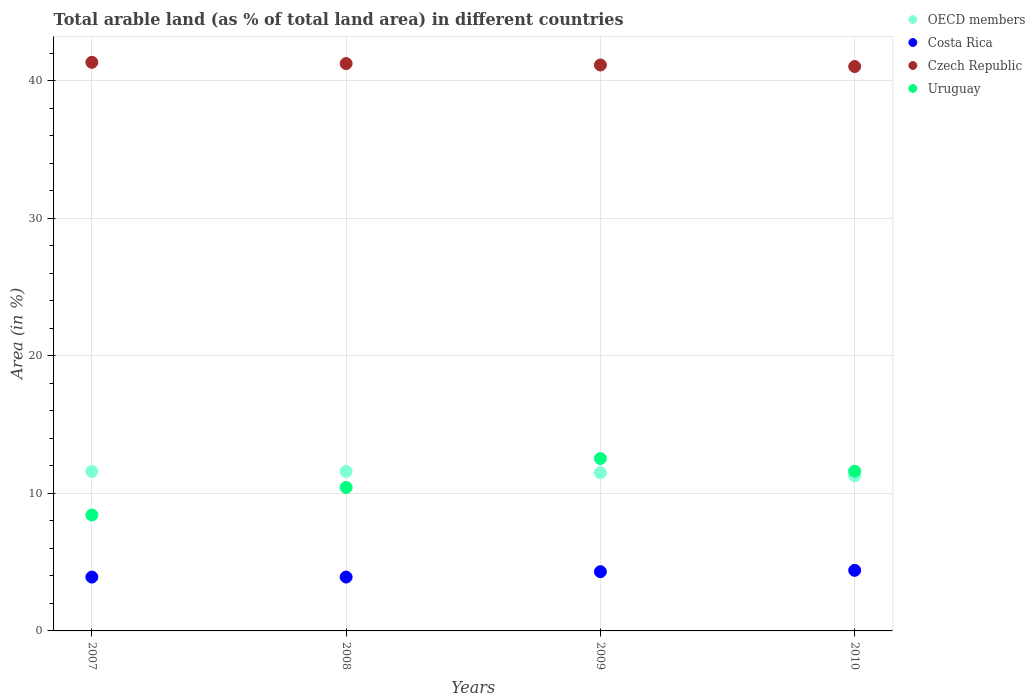What is the percentage of arable land in OECD members in 2009?
Your response must be concise. 11.5. Across all years, what is the maximum percentage of arable land in Costa Rica?
Make the answer very short. 4.41. Across all years, what is the minimum percentage of arable land in OECD members?
Offer a terse response. 11.29. What is the total percentage of arable land in Uruguay in the graph?
Your answer should be very brief. 43.02. What is the difference between the percentage of arable land in Czech Republic in 2007 and that in 2008?
Your answer should be very brief. 0.09. What is the difference between the percentage of arable land in Uruguay in 2007 and the percentage of arable land in Costa Rica in 2010?
Offer a terse response. 4.03. What is the average percentage of arable land in Uruguay per year?
Give a very brief answer. 10.76. In the year 2007, what is the difference between the percentage of arable land in Czech Republic and percentage of arable land in OECD members?
Ensure brevity in your answer.  29.76. In how many years, is the percentage of arable land in Uruguay greater than 40 %?
Your response must be concise. 0. What is the ratio of the percentage of arable land in Czech Republic in 2007 to that in 2009?
Offer a very short reply. 1. What is the difference between the highest and the second highest percentage of arable land in Costa Rica?
Make the answer very short. 0.1. What is the difference between the highest and the lowest percentage of arable land in OECD members?
Provide a short and direct response. 0.32. In how many years, is the percentage of arable land in Costa Rica greater than the average percentage of arable land in Costa Rica taken over all years?
Your answer should be very brief. 2. Is it the case that in every year, the sum of the percentage of arable land in Costa Rica and percentage of arable land in OECD members  is greater than the sum of percentage of arable land in Uruguay and percentage of arable land in Czech Republic?
Keep it short and to the point. No. How many dotlines are there?
Provide a succinct answer. 4. How many years are there in the graph?
Make the answer very short. 4. Are the values on the major ticks of Y-axis written in scientific E-notation?
Make the answer very short. No. Does the graph contain grids?
Your response must be concise. Yes. How are the legend labels stacked?
Offer a terse response. Vertical. What is the title of the graph?
Provide a short and direct response. Total arable land (as % of total land area) in different countries. What is the label or title of the X-axis?
Offer a very short reply. Years. What is the label or title of the Y-axis?
Ensure brevity in your answer.  Area (in %). What is the Area (in %) in OECD members in 2007?
Offer a terse response. 11.6. What is the Area (in %) of Costa Rica in 2007?
Offer a very short reply. 3.92. What is the Area (in %) of Czech Republic in 2007?
Provide a succinct answer. 41.36. What is the Area (in %) of Uruguay in 2007?
Give a very brief answer. 8.43. What is the Area (in %) in OECD members in 2008?
Offer a very short reply. 11.6. What is the Area (in %) in Costa Rica in 2008?
Provide a succinct answer. 3.92. What is the Area (in %) of Czech Republic in 2008?
Give a very brief answer. 41.27. What is the Area (in %) of Uruguay in 2008?
Give a very brief answer. 10.43. What is the Area (in %) in OECD members in 2009?
Offer a very short reply. 11.5. What is the Area (in %) of Costa Rica in 2009?
Your answer should be very brief. 4.31. What is the Area (in %) of Czech Republic in 2009?
Offer a terse response. 41.17. What is the Area (in %) of Uruguay in 2009?
Provide a short and direct response. 12.54. What is the Area (in %) of OECD members in 2010?
Provide a short and direct response. 11.29. What is the Area (in %) of Costa Rica in 2010?
Offer a very short reply. 4.41. What is the Area (in %) in Czech Republic in 2010?
Keep it short and to the point. 41.05. What is the Area (in %) in Uruguay in 2010?
Keep it short and to the point. 11.62. Across all years, what is the maximum Area (in %) of OECD members?
Keep it short and to the point. 11.6. Across all years, what is the maximum Area (in %) of Costa Rica?
Offer a very short reply. 4.41. Across all years, what is the maximum Area (in %) of Czech Republic?
Your answer should be very brief. 41.36. Across all years, what is the maximum Area (in %) of Uruguay?
Offer a terse response. 12.54. Across all years, what is the minimum Area (in %) in OECD members?
Your response must be concise. 11.29. Across all years, what is the minimum Area (in %) in Costa Rica?
Your answer should be compact. 3.92. Across all years, what is the minimum Area (in %) of Czech Republic?
Ensure brevity in your answer.  41.05. Across all years, what is the minimum Area (in %) in Uruguay?
Offer a terse response. 8.43. What is the total Area (in %) in OECD members in the graph?
Your answer should be compact. 45.99. What is the total Area (in %) of Costa Rica in the graph?
Provide a short and direct response. 16.55. What is the total Area (in %) of Czech Republic in the graph?
Keep it short and to the point. 164.85. What is the total Area (in %) of Uruguay in the graph?
Your response must be concise. 43.02. What is the difference between the Area (in %) in OECD members in 2007 and that in 2008?
Your answer should be compact. -0. What is the difference between the Area (in %) in Costa Rica in 2007 and that in 2008?
Your answer should be very brief. 0. What is the difference between the Area (in %) of Czech Republic in 2007 and that in 2008?
Make the answer very short. 0.09. What is the difference between the Area (in %) of Uruguay in 2007 and that in 2008?
Give a very brief answer. -2. What is the difference between the Area (in %) in OECD members in 2007 and that in 2009?
Keep it short and to the point. 0.1. What is the difference between the Area (in %) of Costa Rica in 2007 and that in 2009?
Offer a terse response. -0.39. What is the difference between the Area (in %) of Czech Republic in 2007 and that in 2009?
Keep it short and to the point. 0.19. What is the difference between the Area (in %) of Uruguay in 2007 and that in 2009?
Keep it short and to the point. -4.11. What is the difference between the Area (in %) in OECD members in 2007 and that in 2010?
Make the answer very short. 0.31. What is the difference between the Area (in %) of Costa Rica in 2007 and that in 2010?
Your answer should be very brief. -0.49. What is the difference between the Area (in %) of Czech Republic in 2007 and that in 2010?
Offer a very short reply. 0.31. What is the difference between the Area (in %) in Uruguay in 2007 and that in 2010?
Your answer should be very brief. -3.18. What is the difference between the Area (in %) in OECD members in 2008 and that in 2009?
Give a very brief answer. 0.1. What is the difference between the Area (in %) in Costa Rica in 2008 and that in 2009?
Your response must be concise. -0.39. What is the difference between the Area (in %) of Czech Republic in 2008 and that in 2009?
Keep it short and to the point. 0.1. What is the difference between the Area (in %) in Uruguay in 2008 and that in 2009?
Your answer should be compact. -2.11. What is the difference between the Area (in %) of OECD members in 2008 and that in 2010?
Provide a succinct answer. 0.32. What is the difference between the Area (in %) in Costa Rica in 2008 and that in 2010?
Offer a terse response. -0.49. What is the difference between the Area (in %) in Czech Republic in 2008 and that in 2010?
Keep it short and to the point. 0.21. What is the difference between the Area (in %) of Uruguay in 2008 and that in 2010?
Ensure brevity in your answer.  -1.18. What is the difference between the Area (in %) in OECD members in 2009 and that in 2010?
Offer a very short reply. 0.22. What is the difference between the Area (in %) of Costa Rica in 2009 and that in 2010?
Make the answer very short. -0.1. What is the difference between the Area (in %) in Czech Republic in 2009 and that in 2010?
Offer a very short reply. 0.11. What is the difference between the Area (in %) of Uruguay in 2009 and that in 2010?
Give a very brief answer. 0.93. What is the difference between the Area (in %) of OECD members in 2007 and the Area (in %) of Costa Rica in 2008?
Provide a short and direct response. 7.68. What is the difference between the Area (in %) of OECD members in 2007 and the Area (in %) of Czech Republic in 2008?
Offer a terse response. -29.67. What is the difference between the Area (in %) in OECD members in 2007 and the Area (in %) in Uruguay in 2008?
Your answer should be very brief. 1.17. What is the difference between the Area (in %) in Costa Rica in 2007 and the Area (in %) in Czech Republic in 2008?
Ensure brevity in your answer.  -37.35. What is the difference between the Area (in %) of Costa Rica in 2007 and the Area (in %) of Uruguay in 2008?
Offer a very short reply. -6.52. What is the difference between the Area (in %) of Czech Republic in 2007 and the Area (in %) of Uruguay in 2008?
Your answer should be very brief. 30.93. What is the difference between the Area (in %) of OECD members in 2007 and the Area (in %) of Costa Rica in 2009?
Keep it short and to the point. 7.29. What is the difference between the Area (in %) of OECD members in 2007 and the Area (in %) of Czech Republic in 2009?
Make the answer very short. -29.57. What is the difference between the Area (in %) in OECD members in 2007 and the Area (in %) in Uruguay in 2009?
Offer a terse response. -0.94. What is the difference between the Area (in %) in Costa Rica in 2007 and the Area (in %) in Czech Republic in 2009?
Provide a succinct answer. -37.25. What is the difference between the Area (in %) of Costa Rica in 2007 and the Area (in %) of Uruguay in 2009?
Ensure brevity in your answer.  -8.62. What is the difference between the Area (in %) in Czech Republic in 2007 and the Area (in %) in Uruguay in 2009?
Offer a very short reply. 28.82. What is the difference between the Area (in %) of OECD members in 2007 and the Area (in %) of Costa Rica in 2010?
Give a very brief answer. 7.19. What is the difference between the Area (in %) of OECD members in 2007 and the Area (in %) of Czech Republic in 2010?
Give a very brief answer. -29.45. What is the difference between the Area (in %) in OECD members in 2007 and the Area (in %) in Uruguay in 2010?
Make the answer very short. -0.02. What is the difference between the Area (in %) of Costa Rica in 2007 and the Area (in %) of Czech Republic in 2010?
Your response must be concise. -37.14. What is the difference between the Area (in %) in Costa Rica in 2007 and the Area (in %) in Uruguay in 2010?
Your answer should be compact. -7.7. What is the difference between the Area (in %) of Czech Republic in 2007 and the Area (in %) of Uruguay in 2010?
Keep it short and to the point. 29.74. What is the difference between the Area (in %) in OECD members in 2008 and the Area (in %) in Costa Rica in 2009?
Your answer should be very brief. 7.29. What is the difference between the Area (in %) of OECD members in 2008 and the Area (in %) of Czech Republic in 2009?
Offer a very short reply. -29.56. What is the difference between the Area (in %) in OECD members in 2008 and the Area (in %) in Uruguay in 2009?
Provide a short and direct response. -0.94. What is the difference between the Area (in %) of Costa Rica in 2008 and the Area (in %) of Czech Republic in 2009?
Offer a very short reply. -37.25. What is the difference between the Area (in %) in Costa Rica in 2008 and the Area (in %) in Uruguay in 2009?
Your answer should be very brief. -8.62. What is the difference between the Area (in %) in Czech Republic in 2008 and the Area (in %) in Uruguay in 2009?
Offer a very short reply. 28.73. What is the difference between the Area (in %) of OECD members in 2008 and the Area (in %) of Costa Rica in 2010?
Keep it short and to the point. 7.19. What is the difference between the Area (in %) of OECD members in 2008 and the Area (in %) of Czech Republic in 2010?
Make the answer very short. -29.45. What is the difference between the Area (in %) in OECD members in 2008 and the Area (in %) in Uruguay in 2010?
Provide a short and direct response. -0.01. What is the difference between the Area (in %) of Costa Rica in 2008 and the Area (in %) of Czech Republic in 2010?
Make the answer very short. -37.14. What is the difference between the Area (in %) of Costa Rica in 2008 and the Area (in %) of Uruguay in 2010?
Offer a very short reply. -7.7. What is the difference between the Area (in %) in Czech Republic in 2008 and the Area (in %) in Uruguay in 2010?
Provide a short and direct response. 29.65. What is the difference between the Area (in %) of OECD members in 2009 and the Area (in %) of Costa Rica in 2010?
Make the answer very short. 7.1. What is the difference between the Area (in %) of OECD members in 2009 and the Area (in %) of Czech Republic in 2010?
Give a very brief answer. -29.55. What is the difference between the Area (in %) of OECD members in 2009 and the Area (in %) of Uruguay in 2010?
Give a very brief answer. -0.11. What is the difference between the Area (in %) in Costa Rica in 2009 and the Area (in %) in Czech Republic in 2010?
Offer a very short reply. -36.75. What is the difference between the Area (in %) in Costa Rica in 2009 and the Area (in %) in Uruguay in 2010?
Give a very brief answer. -7.31. What is the difference between the Area (in %) of Czech Republic in 2009 and the Area (in %) of Uruguay in 2010?
Offer a very short reply. 29.55. What is the average Area (in %) of OECD members per year?
Offer a very short reply. 11.5. What is the average Area (in %) in Costa Rica per year?
Offer a terse response. 4.14. What is the average Area (in %) in Czech Republic per year?
Ensure brevity in your answer.  41.21. What is the average Area (in %) of Uruguay per year?
Offer a very short reply. 10.76. In the year 2007, what is the difference between the Area (in %) of OECD members and Area (in %) of Costa Rica?
Keep it short and to the point. 7.68. In the year 2007, what is the difference between the Area (in %) of OECD members and Area (in %) of Czech Republic?
Make the answer very short. -29.76. In the year 2007, what is the difference between the Area (in %) in OECD members and Area (in %) in Uruguay?
Provide a short and direct response. 3.17. In the year 2007, what is the difference between the Area (in %) in Costa Rica and Area (in %) in Czech Republic?
Make the answer very short. -37.44. In the year 2007, what is the difference between the Area (in %) in Costa Rica and Area (in %) in Uruguay?
Keep it short and to the point. -4.52. In the year 2007, what is the difference between the Area (in %) in Czech Republic and Area (in %) in Uruguay?
Offer a very short reply. 32.93. In the year 2008, what is the difference between the Area (in %) in OECD members and Area (in %) in Costa Rica?
Keep it short and to the point. 7.68. In the year 2008, what is the difference between the Area (in %) in OECD members and Area (in %) in Czech Republic?
Provide a succinct answer. -29.67. In the year 2008, what is the difference between the Area (in %) in OECD members and Area (in %) in Uruguay?
Your response must be concise. 1.17. In the year 2008, what is the difference between the Area (in %) of Costa Rica and Area (in %) of Czech Republic?
Provide a short and direct response. -37.35. In the year 2008, what is the difference between the Area (in %) in Costa Rica and Area (in %) in Uruguay?
Keep it short and to the point. -6.52. In the year 2008, what is the difference between the Area (in %) in Czech Republic and Area (in %) in Uruguay?
Provide a succinct answer. 30.84. In the year 2009, what is the difference between the Area (in %) in OECD members and Area (in %) in Costa Rica?
Make the answer very short. 7.2. In the year 2009, what is the difference between the Area (in %) of OECD members and Area (in %) of Czech Republic?
Provide a short and direct response. -29.66. In the year 2009, what is the difference between the Area (in %) in OECD members and Area (in %) in Uruguay?
Make the answer very short. -1.04. In the year 2009, what is the difference between the Area (in %) of Costa Rica and Area (in %) of Czech Republic?
Offer a very short reply. -36.86. In the year 2009, what is the difference between the Area (in %) of Costa Rica and Area (in %) of Uruguay?
Provide a short and direct response. -8.23. In the year 2009, what is the difference between the Area (in %) of Czech Republic and Area (in %) of Uruguay?
Offer a very short reply. 28.62. In the year 2010, what is the difference between the Area (in %) in OECD members and Area (in %) in Costa Rica?
Make the answer very short. 6.88. In the year 2010, what is the difference between the Area (in %) of OECD members and Area (in %) of Czech Republic?
Offer a very short reply. -29.77. In the year 2010, what is the difference between the Area (in %) in OECD members and Area (in %) in Uruguay?
Ensure brevity in your answer.  -0.33. In the year 2010, what is the difference between the Area (in %) in Costa Rica and Area (in %) in Czech Republic?
Your answer should be compact. -36.65. In the year 2010, what is the difference between the Area (in %) of Costa Rica and Area (in %) of Uruguay?
Your answer should be very brief. -7.21. In the year 2010, what is the difference between the Area (in %) of Czech Republic and Area (in %) of Uruguay?
Provide a succinct answer. 29.44. What is the ratio of the Area (in %) in Costa Rica in 2007 to that in 2008?
Offer a terse response. 1. What is the ratio of the Area (in %) of Uruguay in 2007 to that in 2008?
Keep it short and to the point. 0.81. What is the ratio of the Area (in %) of OECD members in 2007 to that in 2009?
Provide a short and direct response. 1.01. What is the ratio of the Area (in %) in Costa Rica in 2007 to that in 2009?
Make the answer very short. 0.91. What is the ratio of the Area (in %) in Uruguay in 2007 to that in 2009?
Offer a terse response. 0.67. What is the ratio of the Area (in %) in OECD members in 2007 to that in 2010?
Provide a succinct answer. 1.03. What is the ratio of the Area (in %) of Czech Republic in 2007 to that in 2010?
Give a very brief answer. 1.01. What is the ratio of the Area (in %) of Uruguay in 2007 to that in 2010?
Provide a succinct answer. 0.73. What is the ratio of the Area (in %) in OECD members in 2008 to that in 2009?
Keep it short and to the point. 1.01. What is the ratio of the Area (in %) in Costa Rica in 2008 to that in 2009?
Give a very brief answer. 0.91. What is the ratio of the Area (in %) of Czech Republic in 2008 to that in 2009?
Give a very brief answer. 1. What is the ratio of the Area (in %) of Uruguay in 2008 to that in 2009?
Your answer should be compact. 0.83. What is the ratio of the Area (in %) of OECD members in 2008 to that in 2010?
Provide a succinct answer. 1.03. What is the ratio of the Area (in %) in Costa Rica in 2008 to that in 2010?
Ensure brevity in your answer.  0.89. What is the ratio of the Area (in %) in Czech Republic in 2008 to that in 2010?
Give a very brief answer. 1.01. What is the ratio of the Area (in %) of Uruguay in 2008 to that in 2010?
Make the answer very short. 0.9. What is the ratio of the Area (in %) in OECD members in 2009 to that in 2010?
Give a very brief answer. 1.02. What is the ratio of the Area (in %) in Costa Rica in 2009 to that in 2010?
Keep it short and to the point. 0.98. What is the ratio of the Area (in %) of Uruguay in 2009 to that in 2010?
Provide a succinct answer. 1.08. What is the difference between the highest and the second highest Area (in %) in Costa Rica?
Keep it short and to the point. 0.1. What is the difference between the highest and the second highest Area (in %) in Czech Republic?
Your response must be concise. 0.09. What is the difference between the highest and the second highest Area (in %) of Uruguay?
Offer a very short reply. 0.93. What is the difference between the highest and the lowest Area (in %) in OECD members?
Keep it short and to the point. 0.32. What is the difference between the highest and the lowest Area (in %) in Costa Rica?
Make the answer very short. 0.49. What is the difference between the highest and the lowest Area (in %) in Czech Republic?
Keep it short and to the point. 0.31. What is the difference between the highest and the lowest Area (in %) of Uruguay?
Provide a succinct answer. 4.11. 